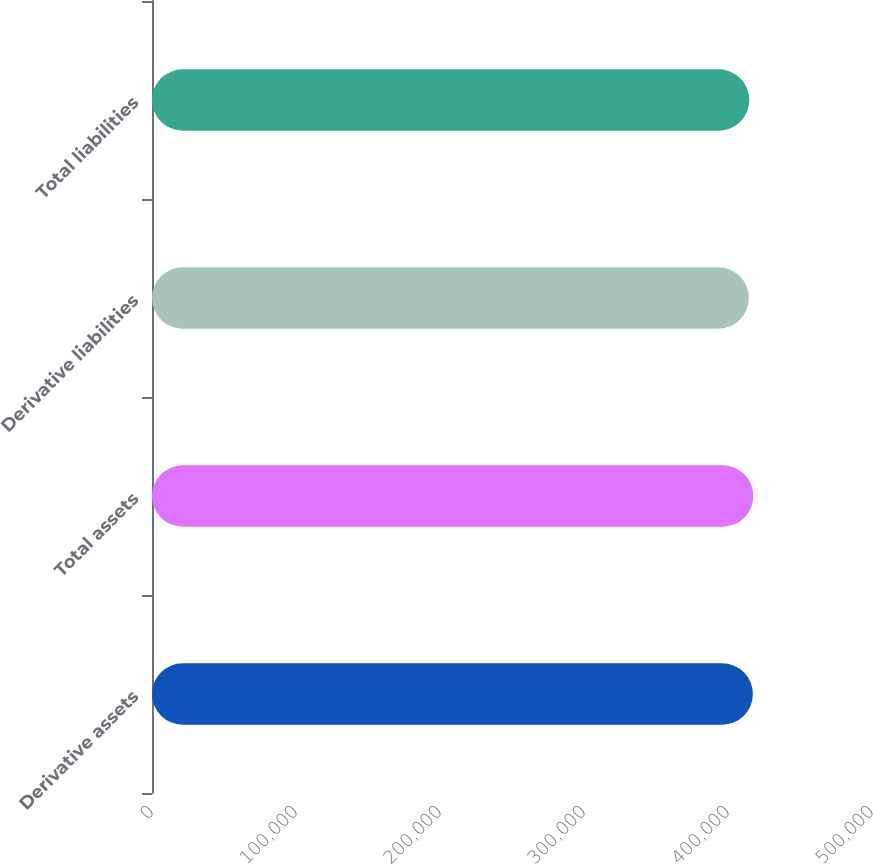Convert chart. <chart><loc_0><loc_0><loc_500><loc_500><bar_chart><fcel>Derivative assets<fcel>Total assets<fcel>Derivative liabilities<fcel>Total liabilities<nl><fcel>417297<fcel>417576<fcel>414509<fcel>414788<nl></chart> 